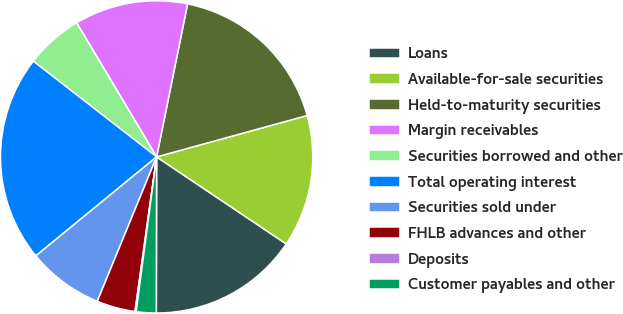Convert chart to OTSL. <chart><loc_0><loc_0><loc_500><loc_500><pie_chart><fcel>Loans<fcel>Available-for-sale securities<fcel>Held-to-maturity securities<fcel>Margin receivables<fcel>Securities borrowed and other<fcel>Total operating interest<fcel>Securities sold under<fcel>FHLB advances and other<fcel>Deposits<fcel>Customer payables and other<nl><fcel>15.62%<fcel>13.68%<fcel>17.55%<fcel>11.74%<fcel>5.93%<fcel>21.43%<fcel>7.87%<fcel>3.99%<fcel>0.12%<fcel>2.06%<nl></chart> 